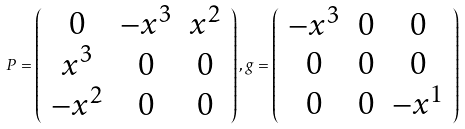<formula> <loc_0><loc_0><loc_500><loc_500>P = \left ( \begin{array} { c c c } 0 & - x ^ { 3 } & x ^ { 2 } \\ x ^ { 3 } & 0 & 0 \\ - x ^ { 2 } & 0 & 0 \\ \end{array} \right ) , { g } = \left ( \begin{array} { c c c } - x ^ { 3 } & 0 & 0 \\ 0 & 0 & 0 \\ 0 & 0 & - x ^ { 1 } \\ \end{array} \right )</formula> 